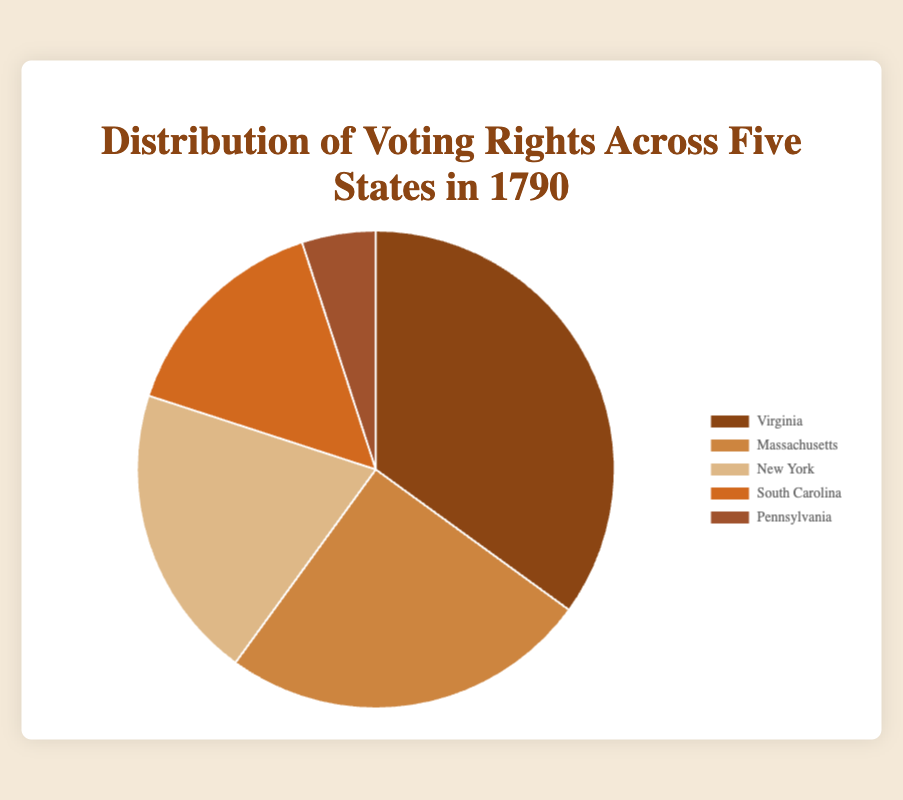Which state has the highest distribution of voting rights? Looking at the pie chart, Virginia has the largest segment, indicating that it has the highest distribution of voting rights among the five states depicted.
Answer: Virginia Which state has the lowest distribution of voting rights? From the pie chart, Pennsylvania has the smallest segment, showing it has the lowest distribution of voting rights.
Answer: Pennsylvania What is the total distribution of voting rights for Massachusetts and New York combined? Adding the voting rights of Massachusetts (25) and New York (20) gives a total of 45%.
Answer: 45% How much higher is Virginia's distribution compared to South Carolina's? Subtracting South Carolina's distribution (15%) from Virginia's (35%) gives the difference: 35% - 15% = 20%.
Answer: 20% What is the average distribution of voting rights across all five states? Adding all percentages (35 + 25 + 20 + 15 + 5) gives 100, and dividing by 5 gives the average: 100 / 5 = 20%.
Answer: 20% Which state has a distribution of voting rights that is greater than New York but less than Virginia? From the pie chart, Massachusetts (25%) fits this criterion as it is greater than New York (20%) but less than Virginia (35%).
Answer: Massachusetts If you combine the distributions of South Carolina and Pennsylvania, will they exceed that of New York? Adding South Carolina's (15%) and Pennsylvania's (5%) gives 20%, which is equal to New York's distribution.
Answer: No Which state occupies the second-largest segment of the pie chart? The chart shows that Massachusetts, with 25%, occupies the second-largest segment.
Answer: Massachusetts What is the combined distribution of voting rights for the two states with the smallest segments? Adding South Carolina's (15%) and Pennsylvania's (5%) gives a total of 20%.
Answer: 20% What is the median value of the distribution percentages across these five states? Arranging the values (5, 15, 20, 25, 35) in ascending order, the middle value, or median, is 20%.
Answer: 20% 